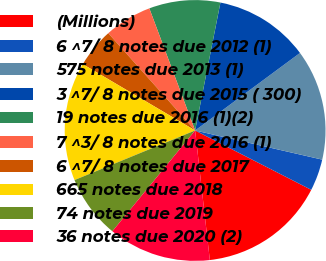Convert chart to OTSL. <chart><loc_0><loc_0><loc_500><loc_500><pie_chart><fcel>(Millions)<fcel>6 ^7/ 8 notes due 2012 (1)<fcel>575 notes due 2013 (1)<fcel>3 ^7/ 8 notes due 2015 ( 300)<fcel>19 notes due 2016 (1)(2)<fcel>7 ^3/ 8 notes due 2016 (1)<fcel>6 ^7/ 8 notes due 2017<fcel>665 notes due 2018<fcel>74 notes due 2019<fcel>36 notes due 2020 (2)<nl><fcel>15.68%<fcel>3.93%<fcel>13.72%<fcel>11.76%<fcel>8.82%<fcel>5.89%<fcel>4.91%<fcel>14.7%<fcel>7.85%<fcel>12.74%<nl></chart> 